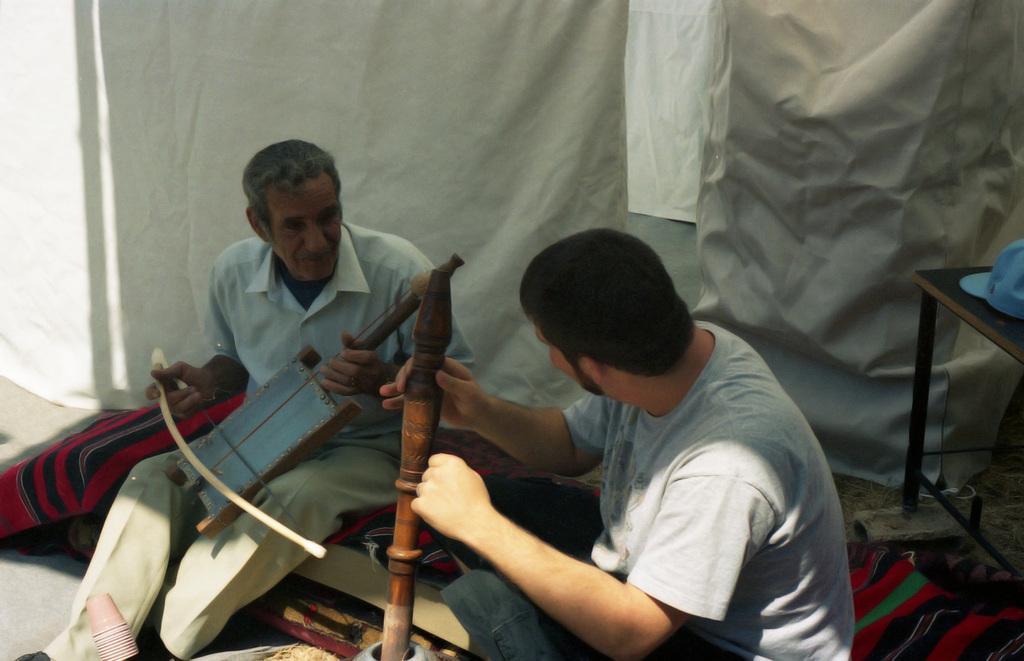Please provide a concise description of this image. As we can see in the image, there are two people sitting and holding musical instruments in their hands. Behind them there is a white color cloth. 